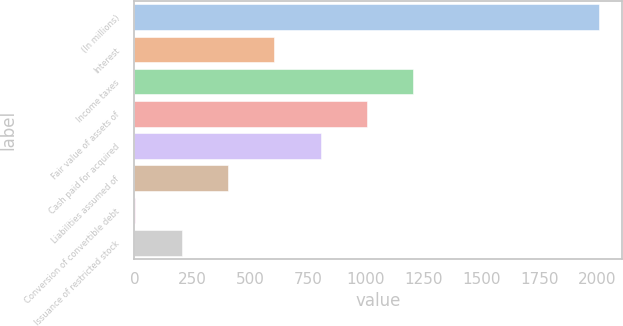Convert chart. <chart><loc_0><loc_0><loc_500><loc_500><bar_chart><fcel>(In millions)<fcel>Interest<fcel>Income taxes<fcel>Fair value of assets of<fcel>Cash paid for acquired<fcel>Liabilities assumed of<fcel>Conversion of convertible debt<fcel>Issuance of restricted stock<nl><fcel>2008<fcel>604.36<fcel>1205.92<fcel>1005.4<fcel>804.88<fcel>403.84<fcel>2.8<fcel>203.32<nl></chart> 